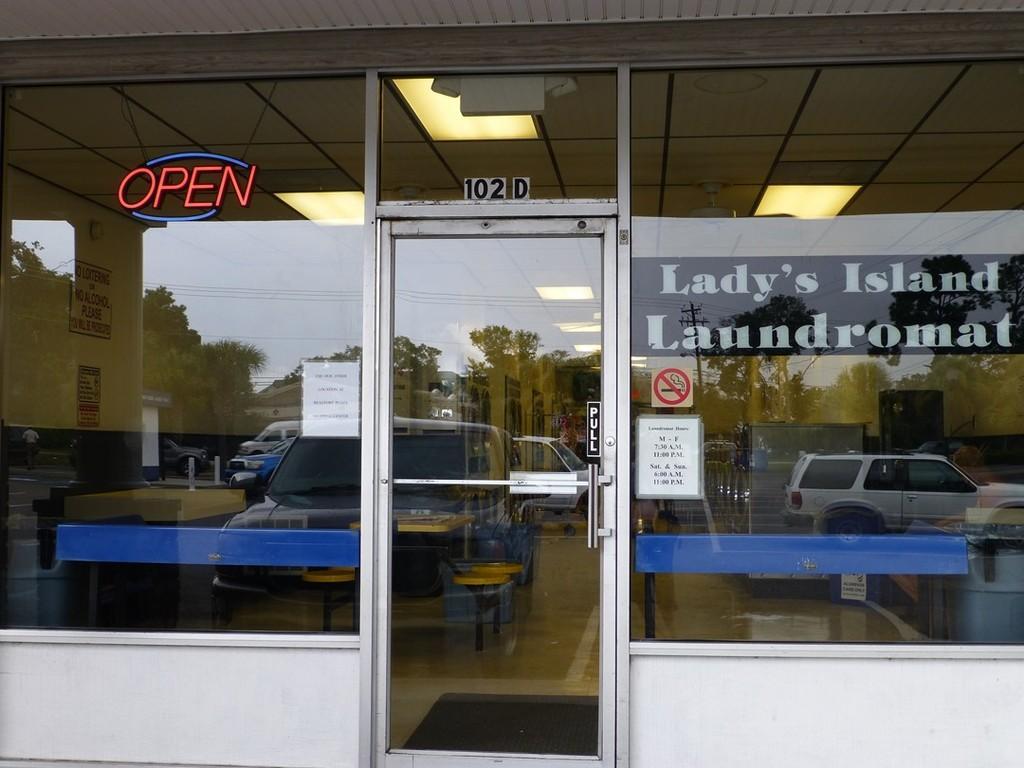Please provide a concise description of this image. In this image I can see a building, door, fleets of vehicles and a board. In the background I can see trees, buildings, light poles, wires, tables, chairs and the sky. This image is taken may be during a day. 